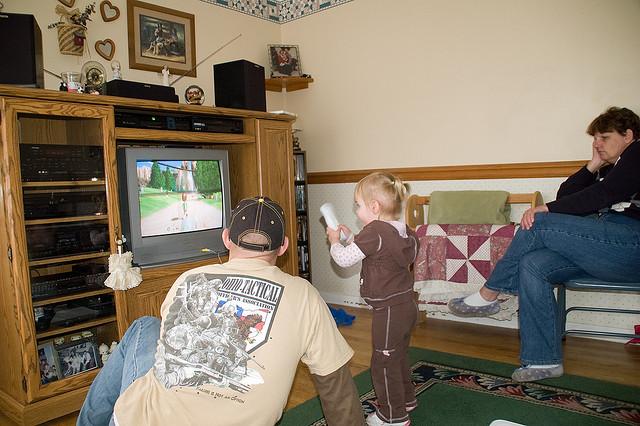What is the guy wearing on his head?
Short answer required. Hat. What game are these people playing?
Be succinct. Wii. Is the woman playing the game?
Give a very brief answer. No. 